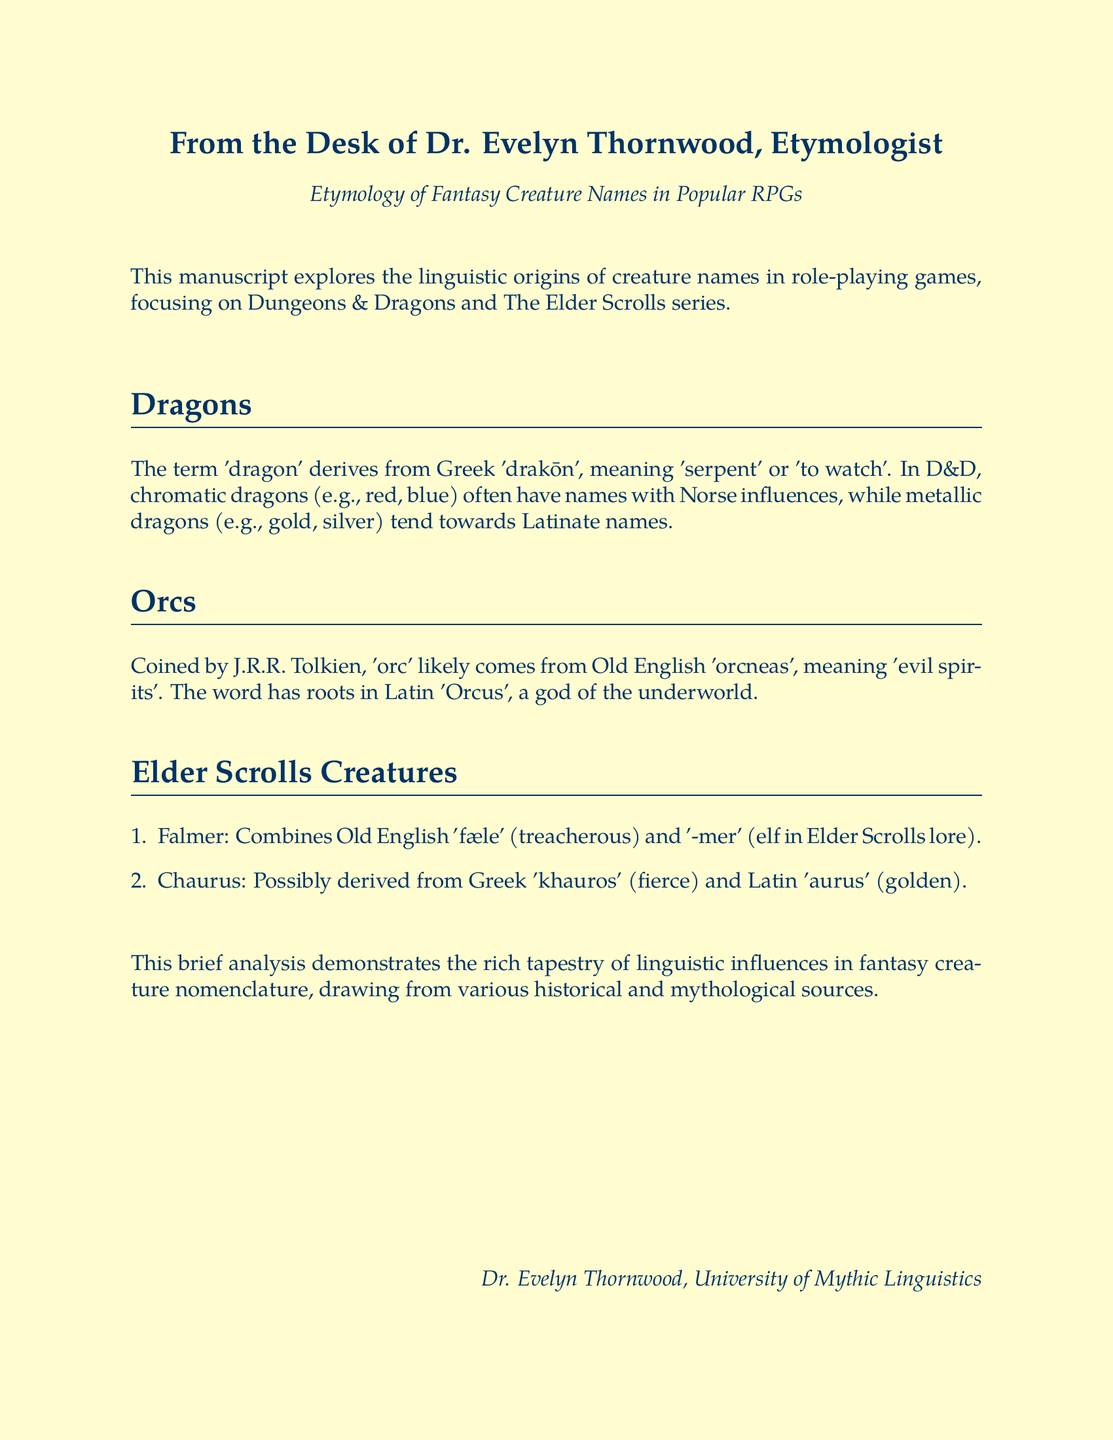What is the author's name? The author's name is provided in the document as Dr. Evelyn Thornwood.
Answer: Dr. Evelyn Thornwood What creature name did J.R.R. Tolkien coin? The document states that Tolkien coined the name 'orc'.
Answer: 'orc' What two sources influence the names of chromatic dragons in D&D? The names of chromatic dragons are influenced by Norse and Latinate sources.
Answer: Norse and Latinate What does the term 'Falmer' combine? 'Falmer' combines Old English 'fæle' and '-mer' from Elder Scrolls lore.
Answer: 'fæle' and '-mer' What does 'dragon' mean in Greek? The term 'dragon' derives from Greek 'drakōn', meaning 'serpent' or 'to watch'.
Answer: serpent or to watch What creature is described as possibly derived from Greek 'khauros'? The document mentions that 'Chaurus' is possibly derived from Greek 'khauros'.
Answer: 'Chaurus' How many examples of Elder Scrolls creatures are given? The document provides two examples of Elder Scrolls creatures, Falmer and Chaurus.
Answer: Two What institution is Dr. Evelyn Thornwood associated with? The document indicates that Dr. Evelyn Thornwood is associated with the University of Mythic Linguistics.
Answer: University of Mythic Linguistics 